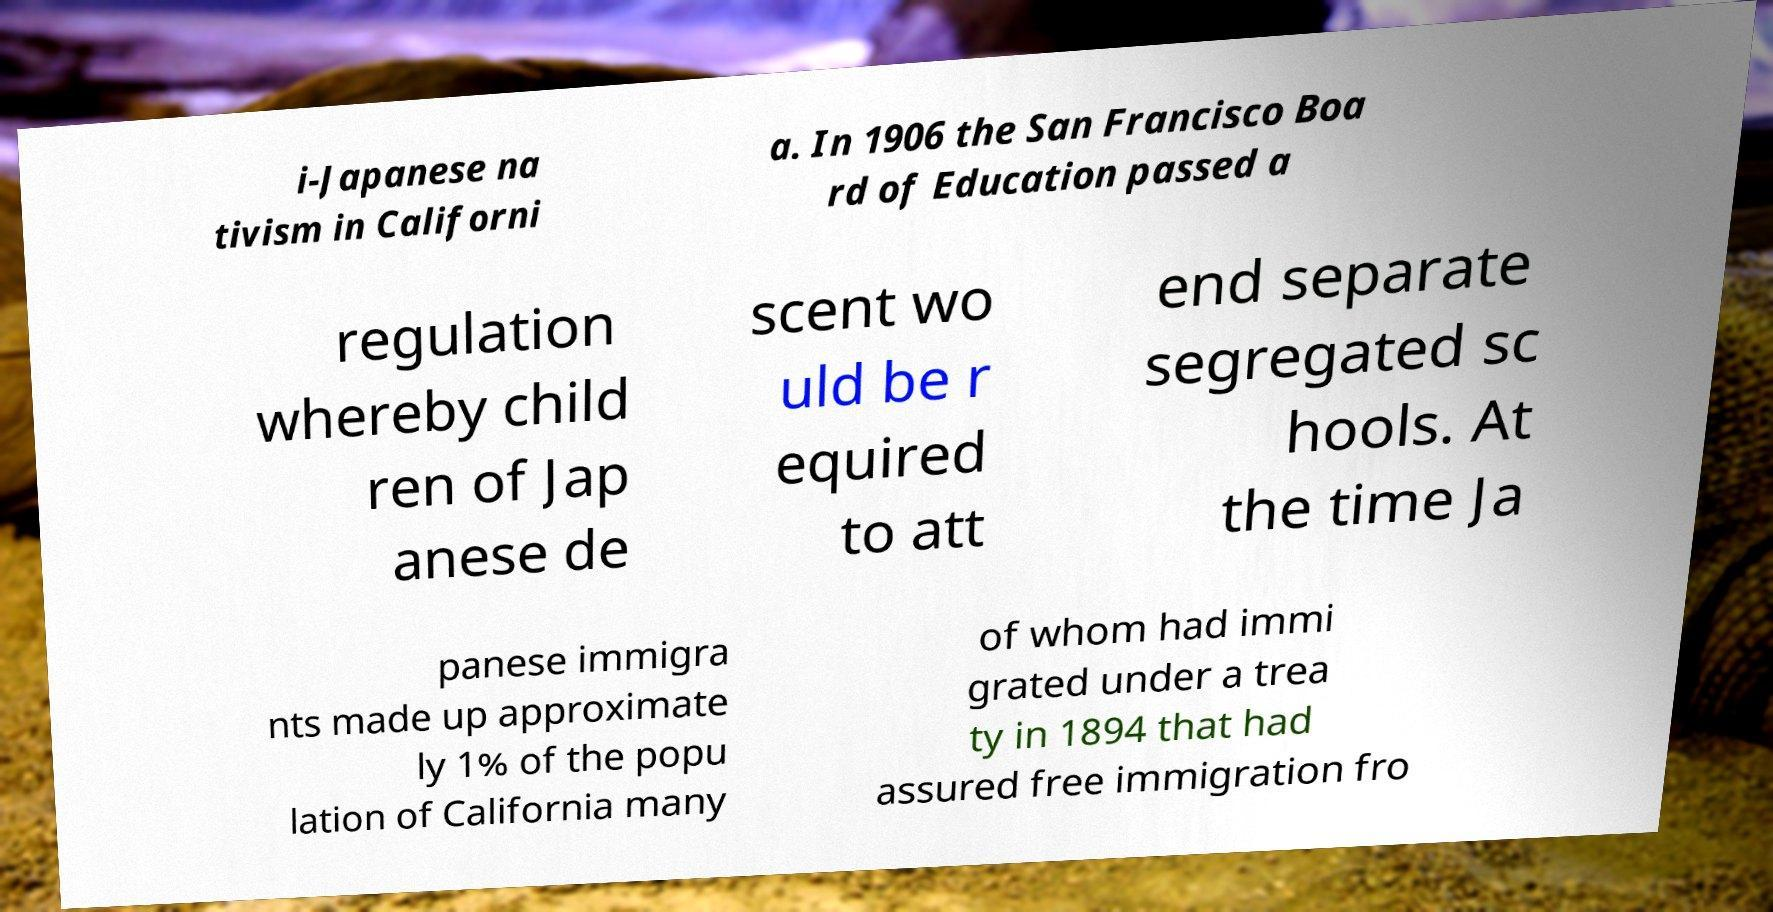Please read and relay the text visible in this image. What does it say? i-Japanese na tivism in Californi a. In 1906 the San Francisco Boa rd of Education passed a regulation whereby child ren of Jap anese de scent wo uld be r equired to att end separate segregated sc hools. At the time Ja panese immigra nts made up approximate ly 1% of the popu lation of California many of whom had immi grated under a trea ty in 1894 that had assured free immigration fro 